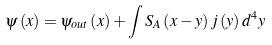Convert formula to latex. <formula><loc_0><loc_0><loc_500><loc_500>\psi \left ( x \right ) = \psi _ { o u t } \left ( x \right ) + \int S _ { A } \left ( x - y \right ) j \left ( y \right ) d ^ { 4 } y</formula> 